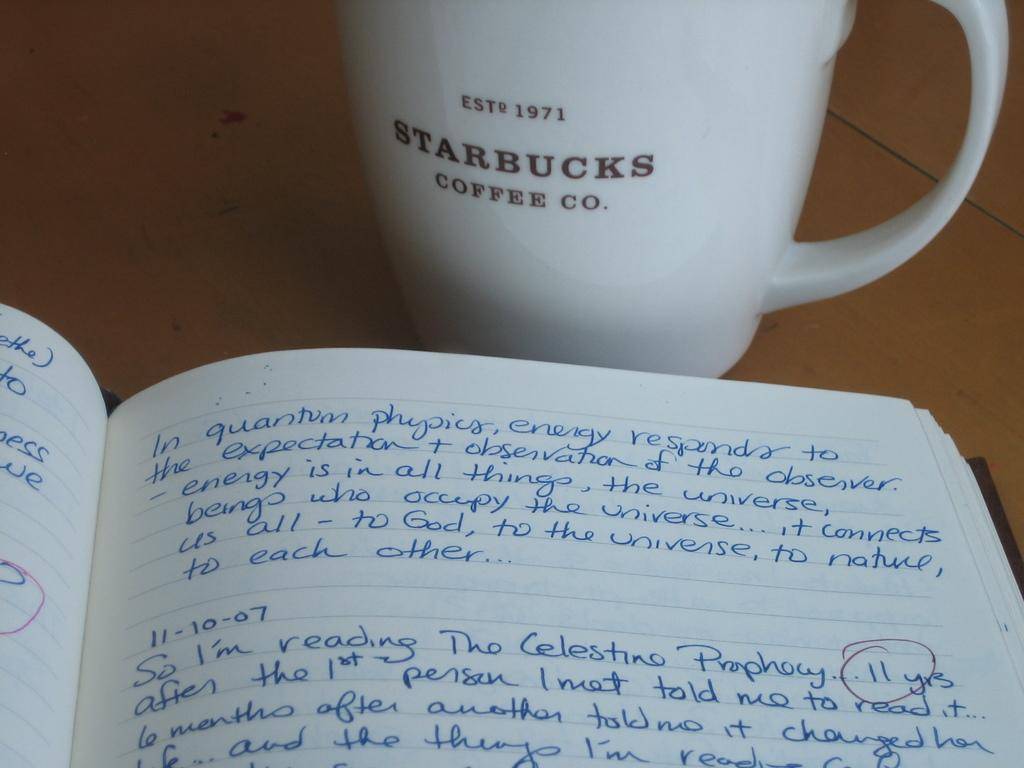What object can be seen in the image that is typically used for reading or learning? There is a book in the image that is typically used for reading or learning. Where is the book located in the image? The book is placed on a table in the image. What other object can be seen in the image that is commonly used for holding liquids? There is a cup in the image that is commonly used for holding liquids. Where is the cup located in the image? The cup is also placed on a table in the image. What type of bead is used to decorate the book in the image? There is no bead present on the book in the image. Can you describe the bird that is perched on the cup in the image? There is no bird present on the cup or anywhere else in the image. 